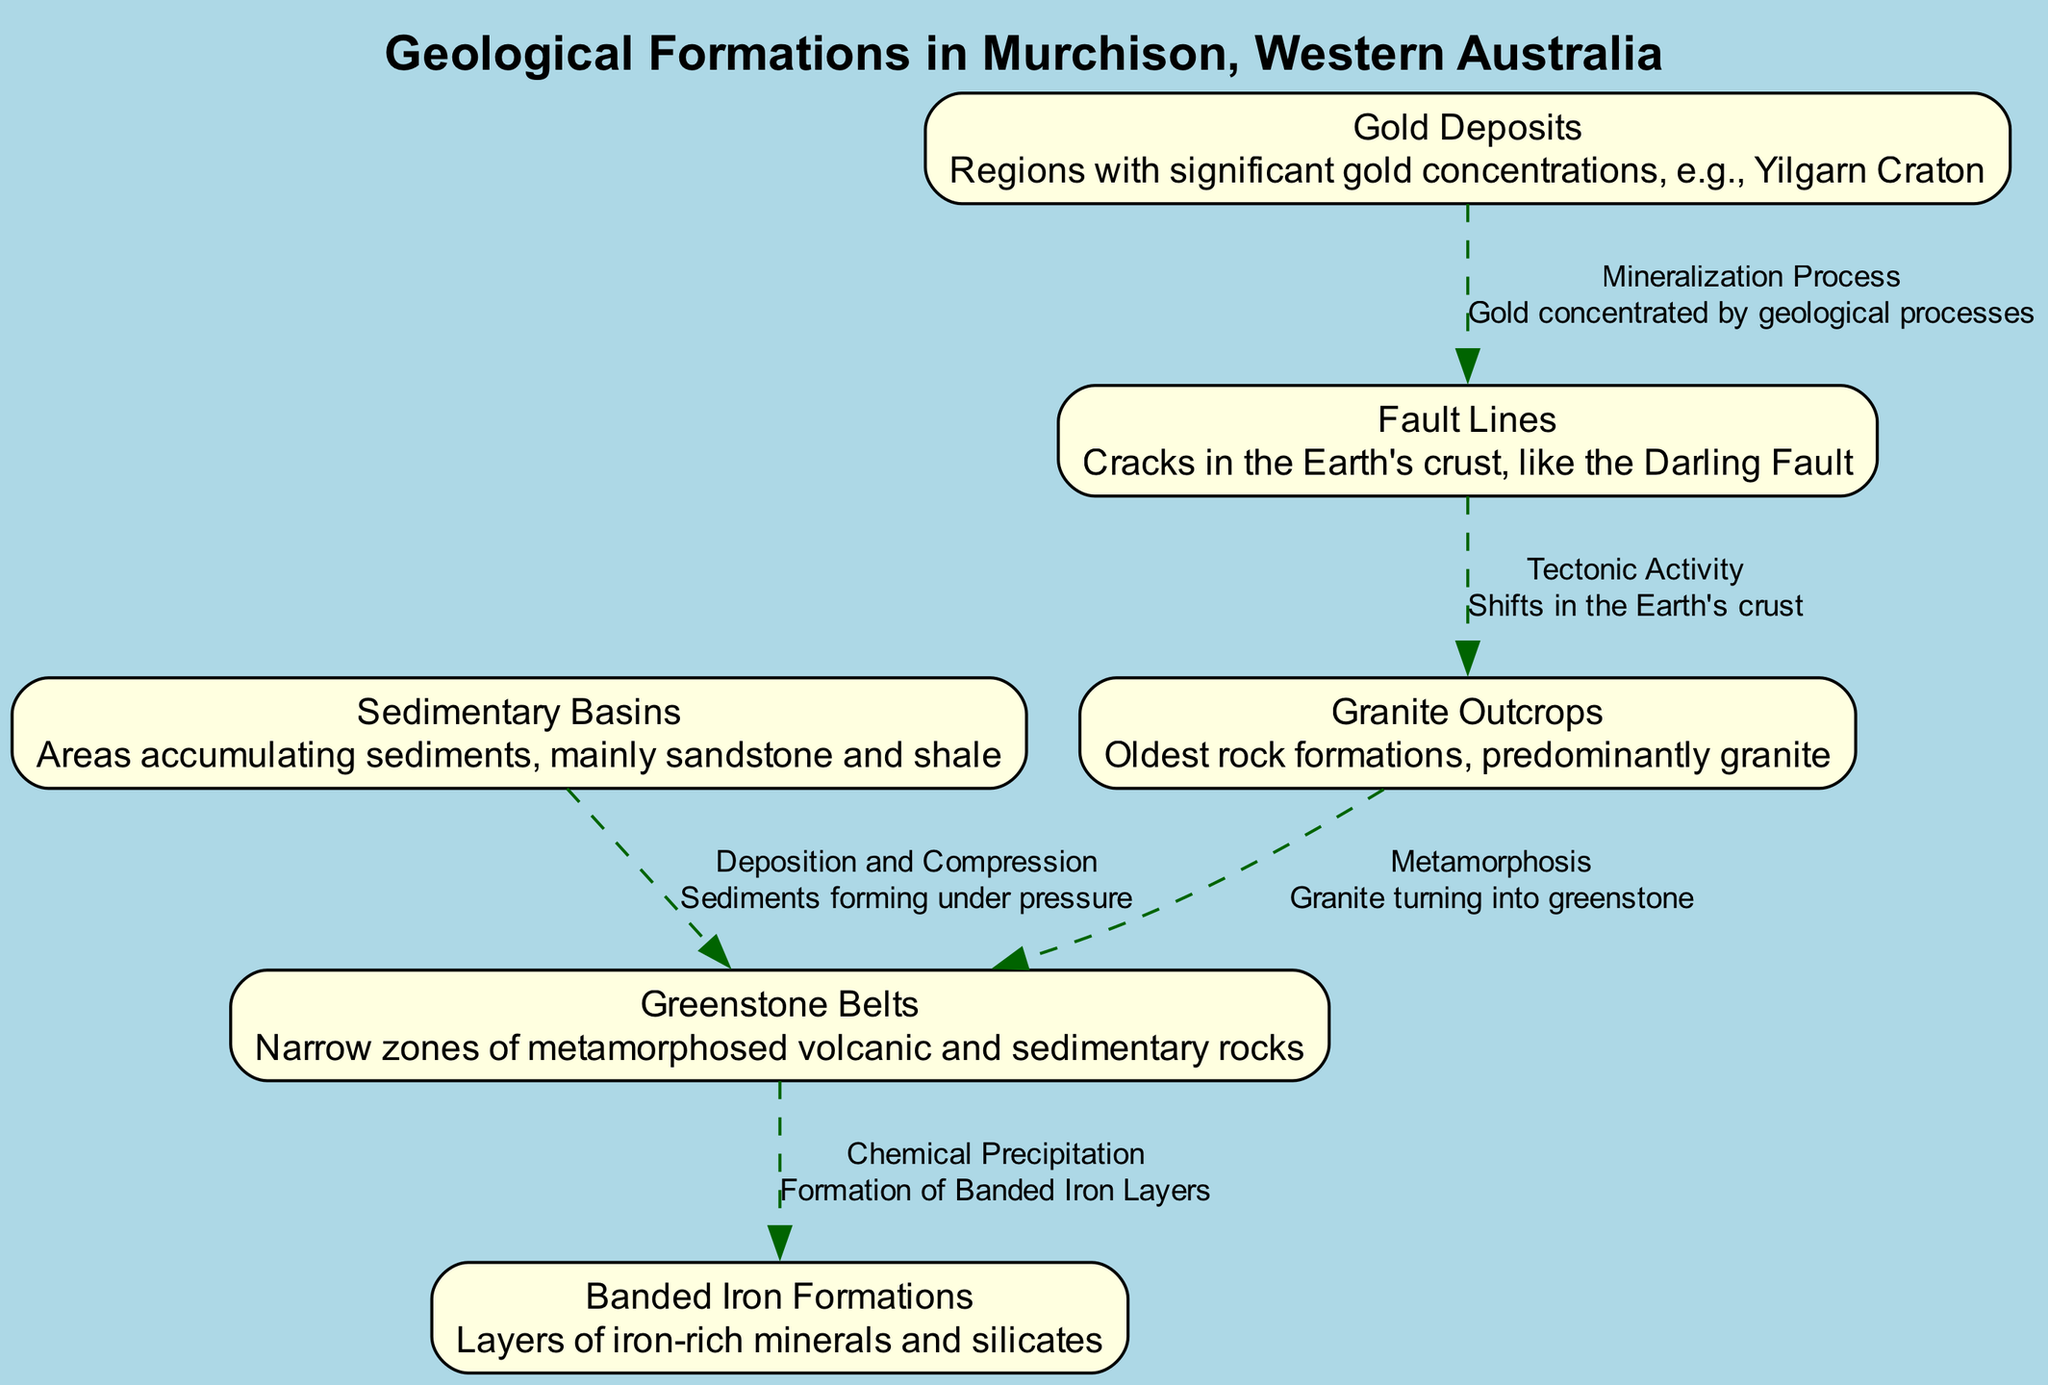What is the oldest rock formation in Murchison? The diagram indicates that the oldest rock formations are the Granite Outcrops, which are specifically labeled.
Answer: Granite Outcrops How many geological features are illustrated in the diagram? By counting the nodes listed in the diagram, we find there are six geological features represented.
Answer: 6 What process describes the relationship between Granite Outcrops and Greenstone Belts? The edge connecting these two nodes is labeled "Metamorphosis," indicating the transformation of granite into greenstone.
Answer: Metamorphosis Which two types of rocks are primarily found in the Sedimentary Basins? The description of the Sedimentary Basins specifies that they mainly accumulate sandstone and shale.
Answer: Sandstone and shale What geological process is responsible for the formation of Banded Iron Layers? The arrow from Greenstone Belts to Banded Iron Formations is labeled "Chemical Precipitation," signifying this process leads to their formation.
Answer: Chemical Precipitation What fault is specifically mentioned in connection with the Fault Lines? The Fault Lines node describes the Darling Fault as an example of a crack in the Earth's crust.
Answer: Darling Fault How are Gold Deposits related to Fault Lines? The edge connecting Gold Deposits to Fault Lines is labeled "Mineralization Process," indicating that geological processes concentrate gold in relation to faulting.
Answer: Mineralization Process What describes the origin of the Greenstone Belts? The diagram states that Greenstone Belts are narrow zones of metamorphosed volcanic and sedimentary rocks, capturing their origin succinctly.
Answer: Metamorphosed volcanic and sedimentary rocks Which geological feature is formed under pressure from sediments? The Sedimentary Basins node indicates that these areas accumulate sediments, which form due to deposition and compression.
Answer: Sedimentary Basins 